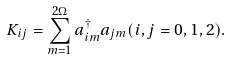Convert formula to latex. <formula><loc_0><loc_0><loc_500><loc_500>K _ { i j } = \sum ^ { 2 \Omega } _ { m = 1 } a ^ { \dagger } _ { i m } a _ { j m } ( i , j = 0 , 1 , 2 ) .</formula> 